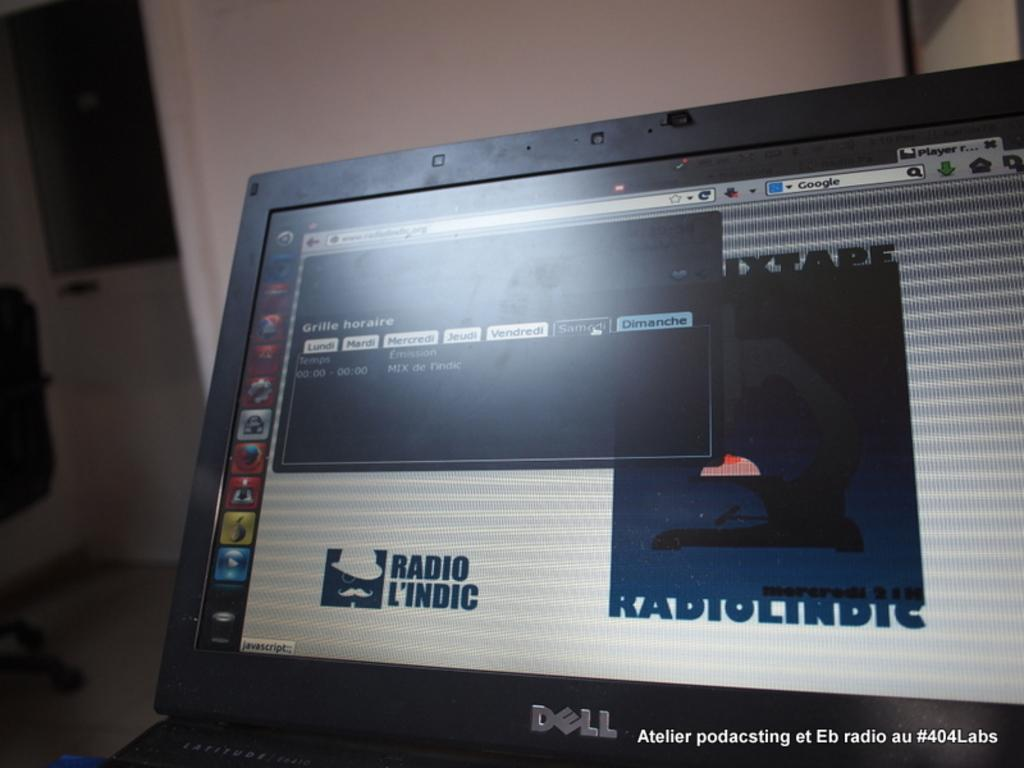What type of electronic device is in the image? There is a black color laptop in the image. Is there any branding on the laptop? Yes, the laptop has a logo on it. What can be seen on the laptop screen? There are icons and text visible on the laptop screen. Can you describe any additional elements in the image? There is a watermark in the image. What type of line is used to represent the mass of the laptop in the image? There is no line or representation of mass in the image; it is a photograph of a laptop with a logo and screen contents. 